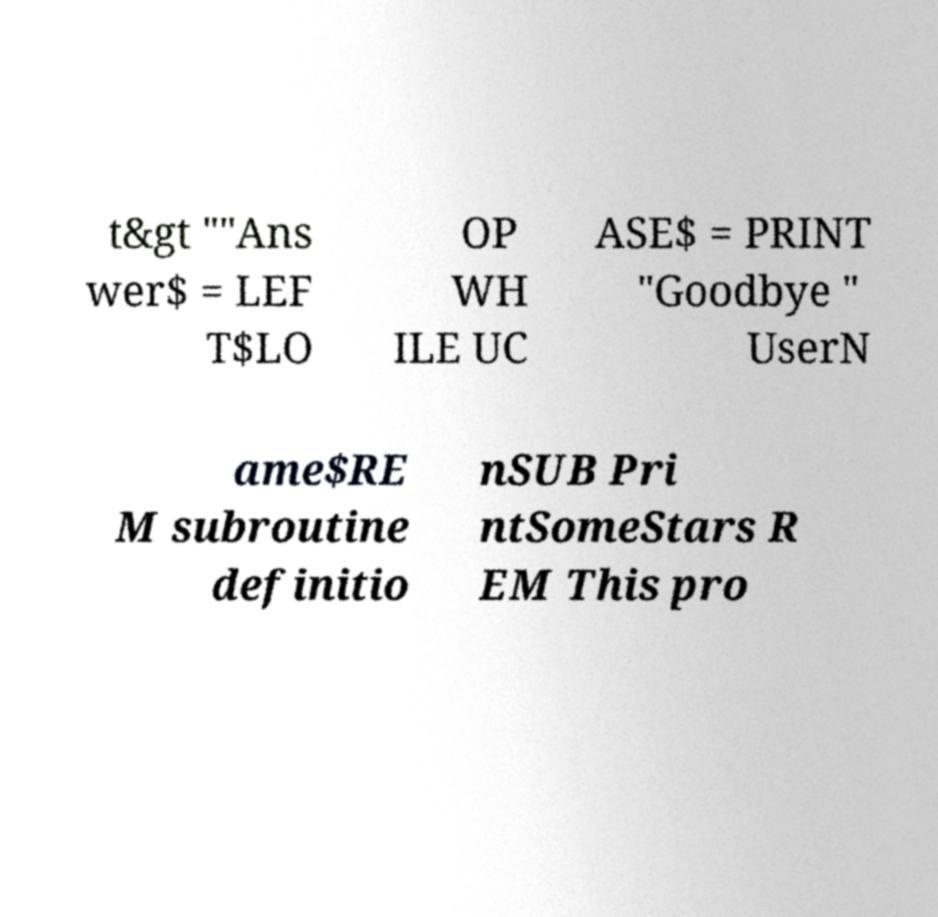There's text embedded in this image that I need extracted. Can you transcribe it verbatim? t&gt ""Ans wer$ = LEF T$LO OP WH ILE UC ASE$ = PRINT "Goodbye " UserN ame$RE M subroutine definitio nSUB Pri ntSomeStars R EM This pro 